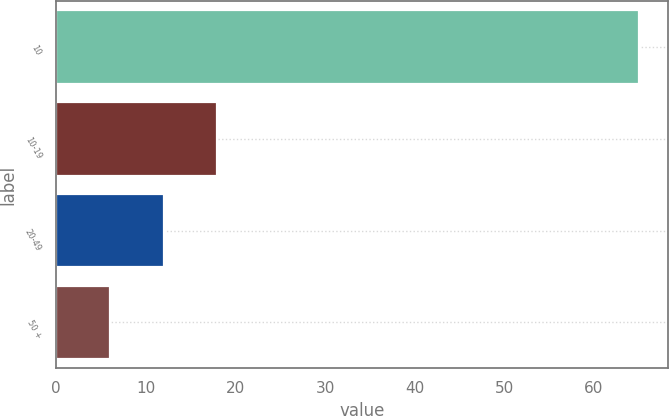<chart> <loc_0><loc_0><loc_500><loc_500><bar_chart><fcel>10<fcel>10-19<fcel>20-49<fcel>50 +<nl><fcel>65<fcel>17.9<fcel>12<fcel>6<nl></chart> 